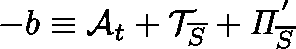Convert formula to latex. <formula><loc_0><loc_0><loc_500><loc_500>- b \equiv \mathcal { A } _ { t } + \mathcal { T } _ { \overline { S } } + \Pi _ { \overline { S } } ^ { ^ { \prime } }</formula> 